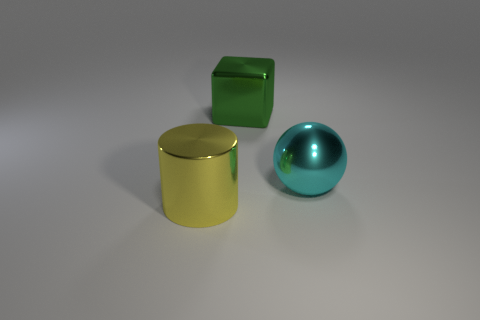Does the large thing that is behind the cyan metallic object have the same material as the thing that is in front of the big cyan metal sphere?
Make the answer very short. Yes. What number of objects are either big cyan things or big metallic things on the right side of the metallic block?
Make the answer very short. 1. Are there any purple shiny objects that have the same shape as the cyan metallic object?
Provide a succinct answer. No. What size is the metallic object that is to the right of the large thing behind the shiny thing that is to the right of the big shiny cube?
Keep it short and to the point. Large. Is the number of yellow things that are in front of the yellow shiny thing the same as the number of large metallic cylinders that are on the right side of the big green block?
Make the answer very short. Yes. What is the size of the cyan sphere that is made of the same material as the big cube?
Provide a short and direct response. Large. The large metallic cylinder has what color?
Make the answer very short. Yellow. How many other spheres have the same color as the large ball?
Make the answer very short. 0. Is there a green metallic thing that is left of the large object that is right of the green shiny cube?
Your response must be concise. Yes. Is there a small green metallic sphere?
Provide a short and direct response. No. 